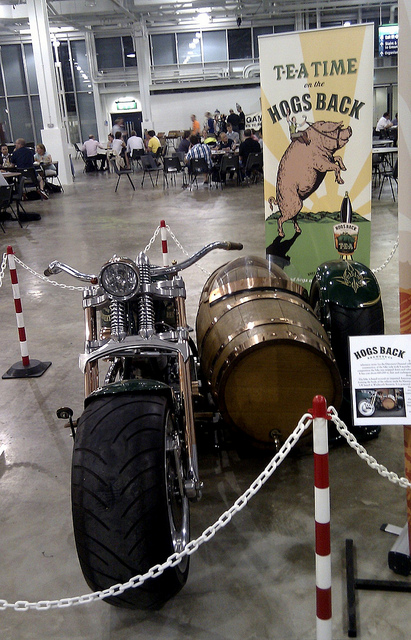Identify the text contained in this image. T-E-A TIME HOGS BACK TEA BACK HOGS 